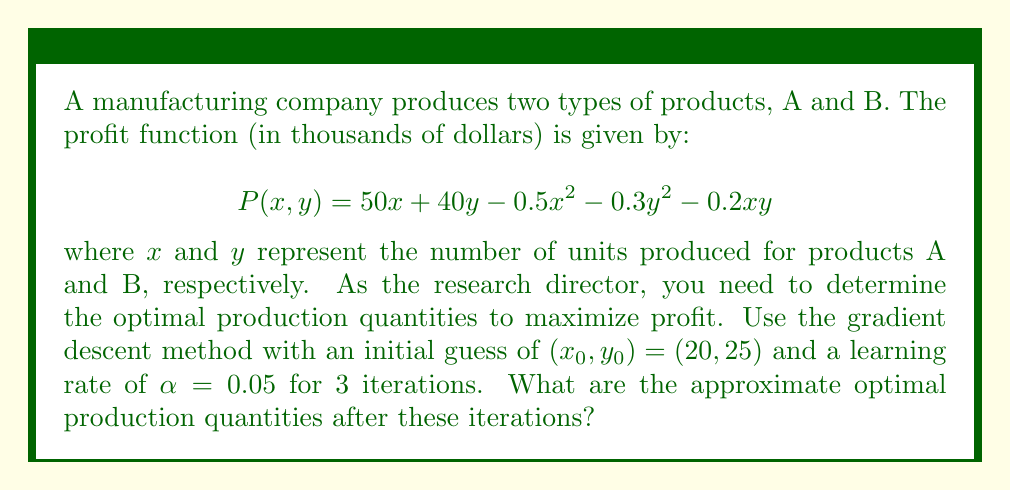Could you help me with this problem? To solve this problem using gradient descent, we follow these steps:

1) First, we need to calculate the gradient of the profit function:
   $$\nabla P = \begin{bmatrix}
   \frac{\partial P}{\partial x} \\
   \frac{\partial P}{\partial y}
   \end{bmatrix} = \begin{bmatrix}
   50 - x - 0.2y \\
   40 - 0.6y - 0.2x
   \end{bmatrix}$$

2) We then apply the gradient descent formula for 3 iterations:
   $$(x_{n+1}, y_{n+1}) = (x_n, y_n) + \alpha \nabla P(x_n, y_n)$$

3) Iteration 1:
   $\nabla P(20, 25) = (25, 15)$
   $(x_1, y_1) = (20, 25) + 0.05(25, 15) = (21.25, 25.75)$

4) Iteration 2:
   $\nabla P(21.25, 25.75) = (23.605, 13.595)$
   $(x_2, y_2) = (21.25, 25.75) + 0.05(23.605, 13.595) = (22.43025, 26.42975)$

5) Iteration 3:
   $\nabla P(22.43025, 26.42975) = (22.2739, 12.2739)$
   $(x_3, y_3) = (22.43025, 26.42975) + 0.05(22.2739, 12.2739) = (23.54395, 27.04345)$

Therefore, after 3 iterations, the approximate optimal production quantities are $x \approx 23.54$ and $y \approx 27.04$ units.
Answer: $(23.54, 27.04)$ 